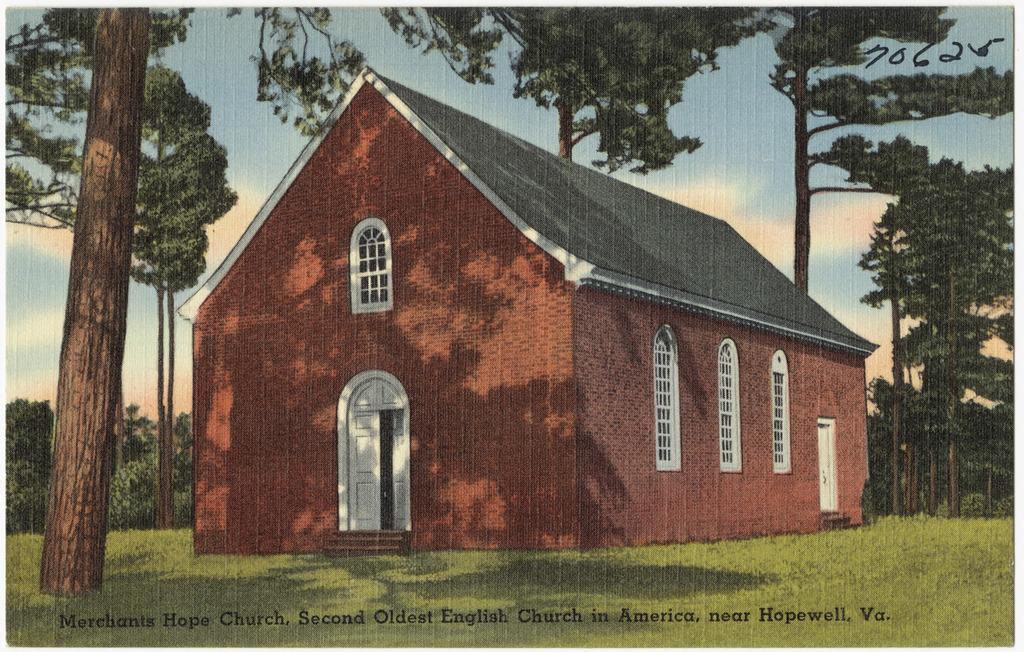In one or two sentences, can you explain what this image depicts? In the picture I can see the painting of a house, grass, trees and the sky with clouds in the background. Here I can see some edited text at the bottom of the image. 